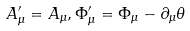Convert formula to latex. <formula><loc_0><loc_0><loc_500><loc_500>A _ { \mu } ^ { \prime } = A _ { \mu } , \Phi _ { \mu } ^ { \prime } = \Phi _ { \mu } - \partial _ { \mu } \theta</formula> 